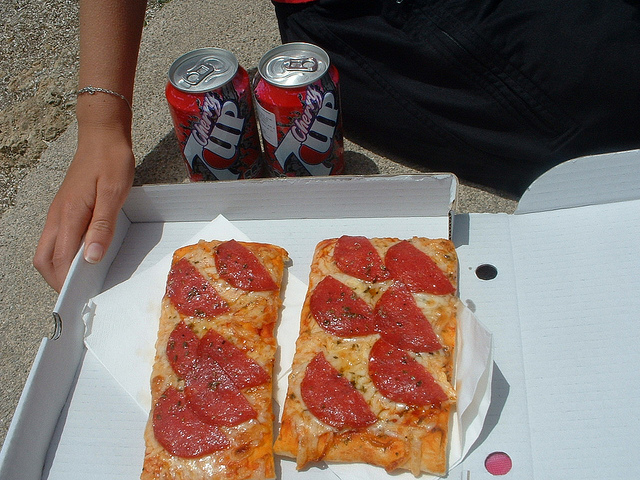<image>Which plate has more slices? I am not sure which plate has more slices. It can be neither, left or right. Which plate has more slices? It is ambiguous which plate has more slices. 